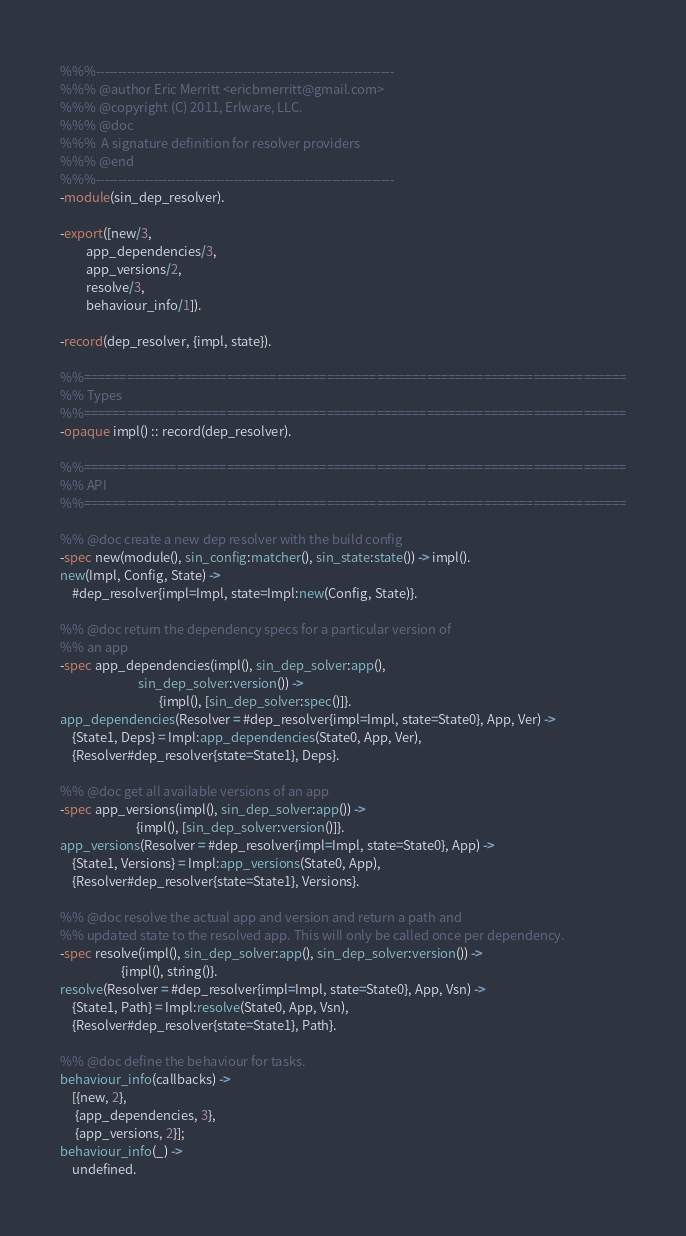<code> <loc_0><loc_0><loc_500><loc_500><_Erlang_>%%%-------------------------------------------------------------------
%%% @author Eric Merritt <ericbmerritt@gmail.com>
%%% @copyright (C) 2011, Erlware, LLC.
%%% @doc
%%%  A signature definition for resolver providers
%%% @end
%%%-------------------------------------------------------------------
-module(sin_dep_resolver).

-export([new/3,
         app_dependencies/3,
         app_versions/2,
         resolve/3,
         behaviour_info/1]).

-record(dep_resolver, {impl, state}).

%%============================================================================
%% Types
%%============================================================================
-opaque impl() :: record(dep_resolver).

%%============================================================================
%% API
%%============================================================================

%% @doc create a new dep resolver with the build config
-spec new(module(), sin_config:matcher(), sin_state:state()) -> impl().
new(Impl, Config, State) ->
    #dep_resolver{impl=Impl, state=Impl:new(Config, State)}.

%% @doc return the dependency specs for a particular version of
%% an app
-spec app_dependencies(impl(), sin_dep_solver:app(),
                           sin_dep_solver:version()) ->
                                  {impl(), [sin_dep_solver:spec()]}.
app_dependencies(Resolver = #dep_resolver{impl=Impl, state=State0}, App, Ver) ->
    {State1, Deps} = Impl:app_dependencies(State0, App, Ver),
    {Resolver#dep_resolver{state=State1}, Deps}.

%% @doc get all available versions of an app
-spec app_versions(impl(), sin_dep_solver:app()) ->
                          {impl(), [sin_dep_solver:version()]}.
app_versions(Resolver = #dep_resolver{impl=Impl, state=State0}, App) ->
    {State1, Versions} = Impl:app_versions(State0, App),
    {Resolver#dep_resolver{state=State1}, Versions}.

%% @doc resolve the actual app and version and return a path and
%% updated state to the resolved app. This will only be called once per dependency.
-spec resolve(impl(), sin_dep_solver:app(), sin_dep_solver:version()) ->
                     {impl(), string()}.
resolve(Resolver = #dep_resolver{impl=Impl, state=State0}, App, Vsn) ->
    {State1, Path} = Impl:resolve(State0, App, Vsn),
    {Resolver#dep_resolver{state=State1}, Path}.

%% @doc define the behaviour for tasks.
behaviour_info(callbacks) ->
    [{new, 2},
     {app_dependencies, 3},
     {app_versions, 2}];
behaviour_info(_) ->
    undefined.
</code> 